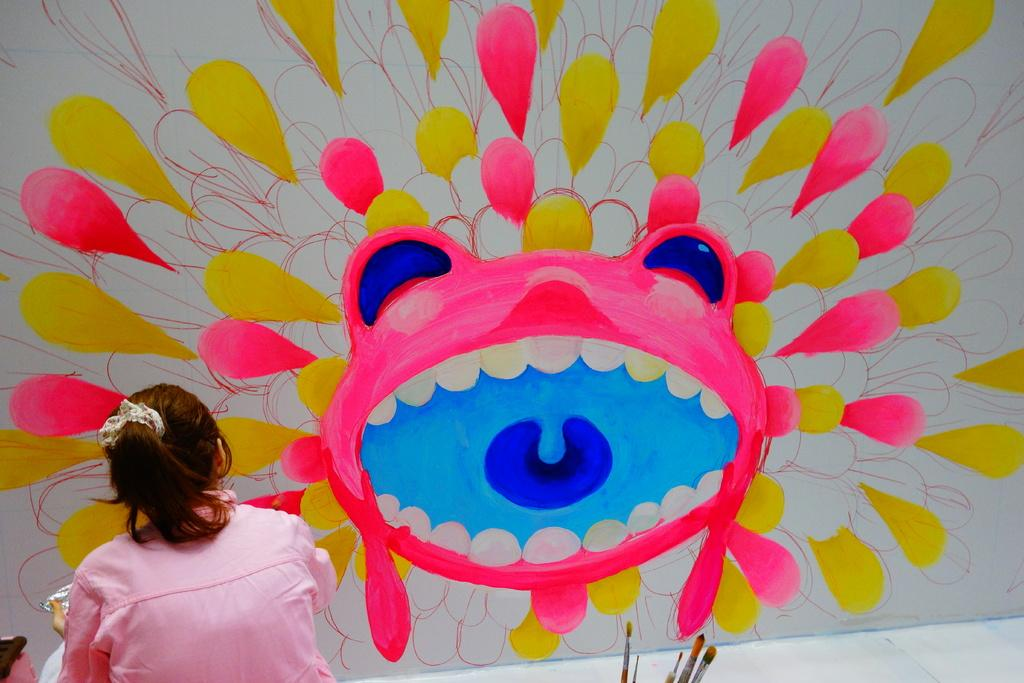What is the main subject of the image? There is a girl standing in the image. Can you describe the medium of the image? The image is likely a painting. What tools are visible at the bottom of the image? Paint brushes are visible at the bottom of the image. What direction is the girl facing in the image? The provided facts do not specify the direction the girl is facing in the image. --- 